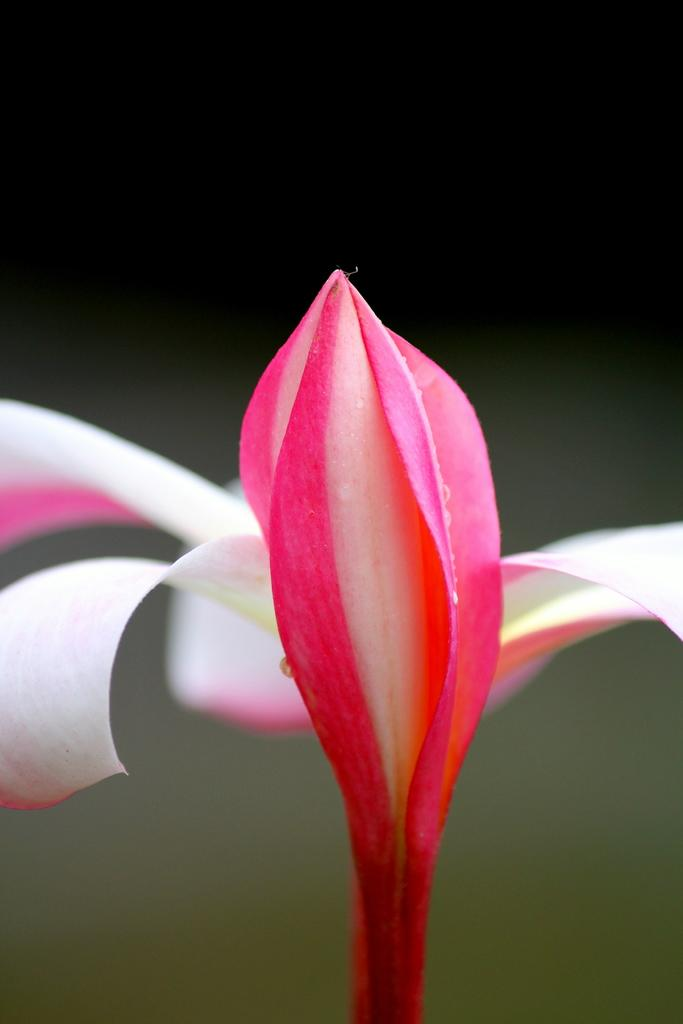What is the main subject of the image? There is a colorful flower in the image. What can be observed about the background of the image? The background of the image is dark. How many planes are visible in the image? There are no planes present in the image; it features a colorful flower. What type of nest can be seen in the image? There is no nest present in the image; it features a colorful flower. 